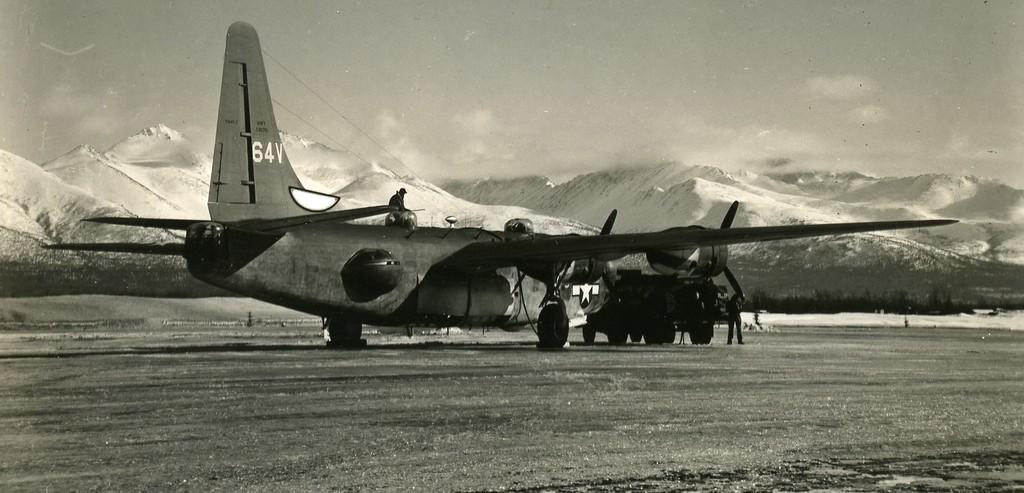What is the main subject in the foreground of the image? There is a plane on the ground in the foreground of the image. Are there any people present in the foreground of the image? Yes, there is a man standing in the foreground of the image. Can you describe the position of the second man in the image? There is a man on top of the plane in the foreground of the image. What can be seen in the background of the image? Mountains and the sky are visible in the background of the image. How many sheep are visible on the plane in the image? There are no sheep present on the plane or in the image. What type of unit is being used to measure the distance between the mountains in the image? There is no unit mentioned or visible in the image to measure the distance between the mountains. 